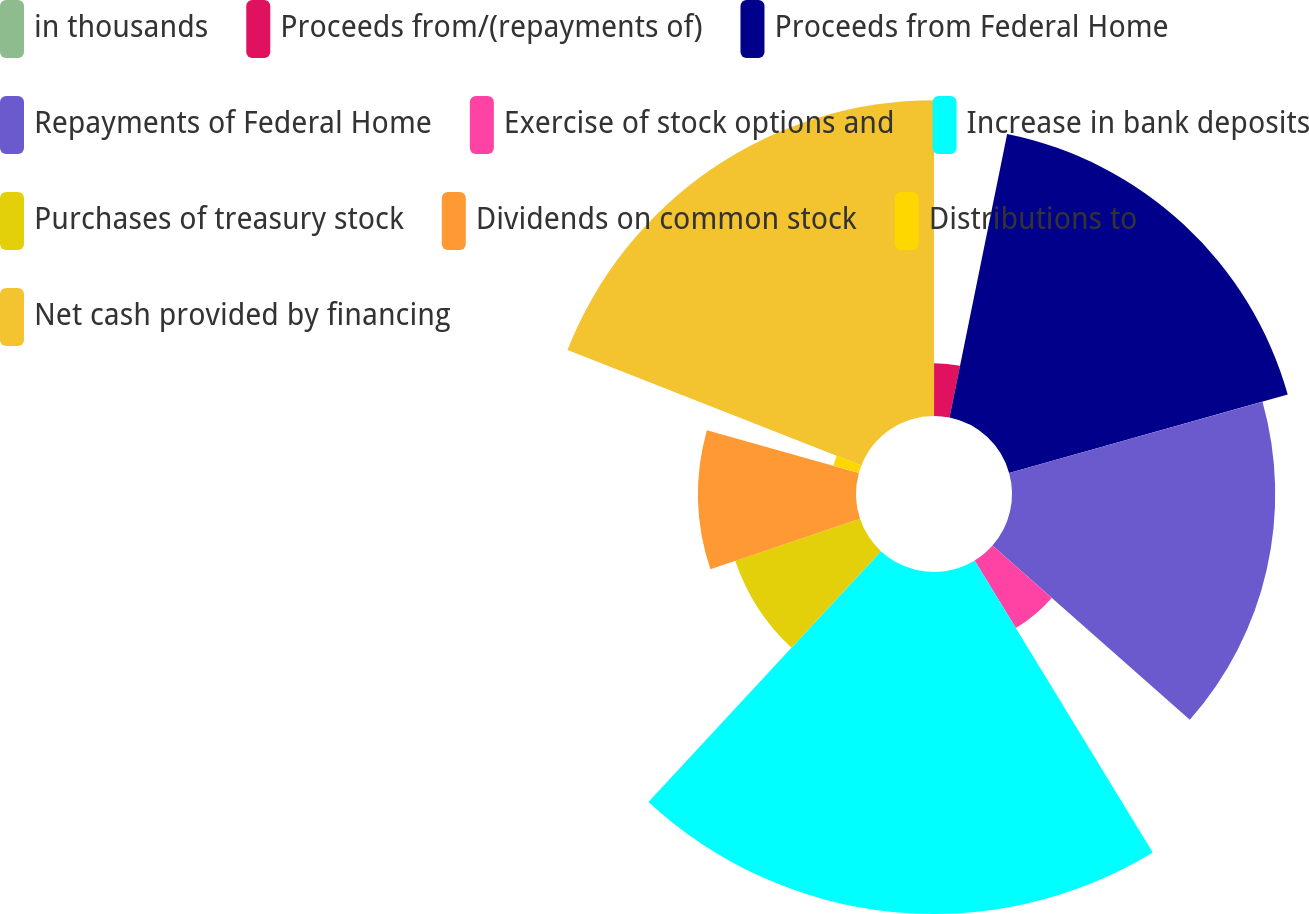Convert chart to OTSL. <chart><loc_0><loc_0><loc_500><loc_500><pie_chart><fcel>in thousands<fcel>Proceeds from/(repayments of)<fcel>Proceeds from Federal Home<fcel>Repayments of Federal Home<fcel>Exercise of stock options and<fcel>Increase in bank deposits<fcel>Purchases of treasury stock<fcel>Dividends on common stock<fcel>Distributions to<fcel>Net cash provided by financing<nl><fcel>0.01%<fcel>3.18%<fcel>17.45%<fcel>15.87%<fcel>4.77%<fcel>20.62%<fcel>7.94%<fcel>9.52%<fcel>1.6%<fcel>19.04%<nl></chart> 